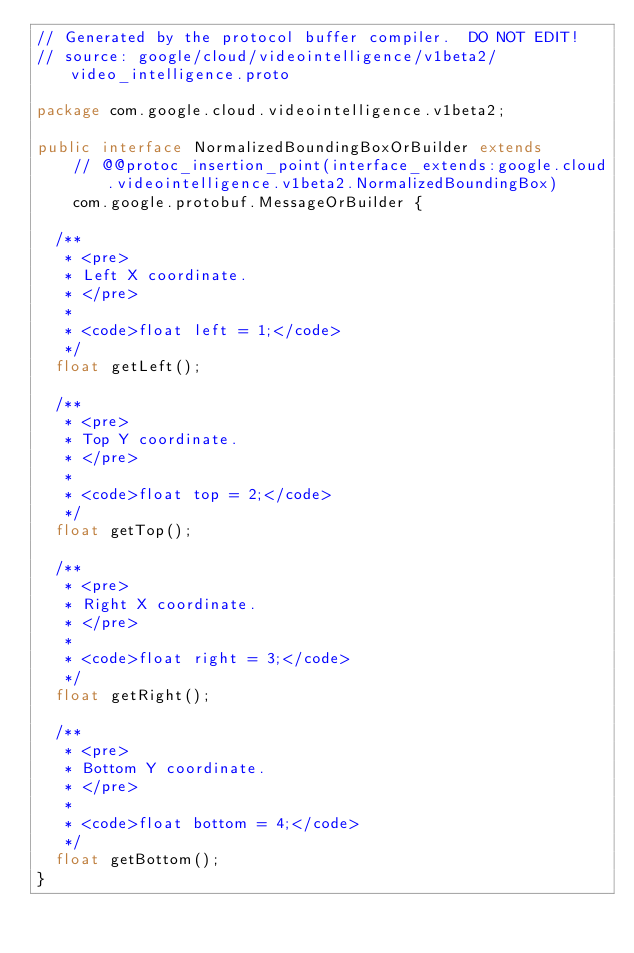Convert code to text. <code><loc_0><loc_0><loc_500><loc_500><_Java_>// Generated by the protocol buffer compiler.  DO NOT EDIT!
// source: google/cloud/videointelligence/v1beta2/video_intelligence.proto

package com.google.cloud.videointelligence.v1beta2;

public interface NormalizedBoundingBoxOrBuilder extends
    // @@protoc_insertion_point(interface_extends:google.cloud.videointelligence.v1beta2.NormalizedBoundingBox)
    com.google.protobuf.MessageOrBuilder {

  /**
   * <pre>
   * Left X coordinate.
   * </pre>
   *
   * <code>float left = 1;</code>
   */
  float getLeft();

  /**
   * <pre>
   * Top Y coordinate.
   * </pre>
   *
   * <code>float top = 2;</code>
   */
  float getTop();

  /**
   * <pre>
   * Right X coordinate.
   * </pre>
   *
   * <code>float right = 3;</code>
   */
  float getRight();

  /**
   * <pre>
   * Bottom Y coordinate.
   * </pre>
   *
   * <code>float bottom = 4;</code>
   */
  float getBottom();
}
</code> 